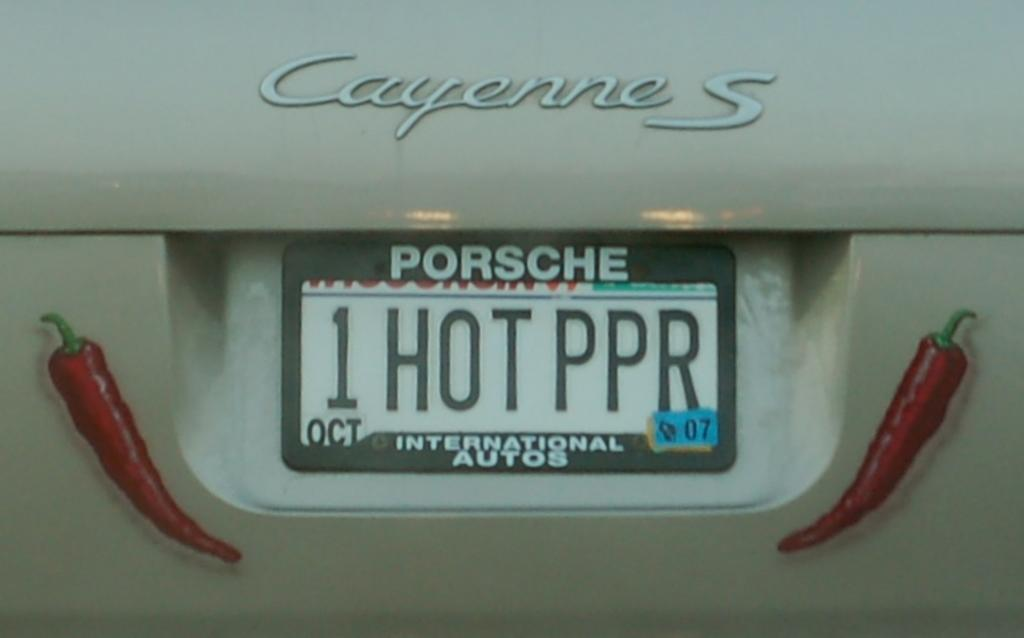What is the main subject in the foreground of the image? There is a number plate of a vehicle in the foreground of the image. What can be seen on the number plate? There is some text on the number plate. Are there any additional elements on the number plate? Yes, there are stickers on the number plate. What type of bear can be seen holding the earth on the number plate? There is no bear or earth present on the number plate; it only contains text and stickers. 